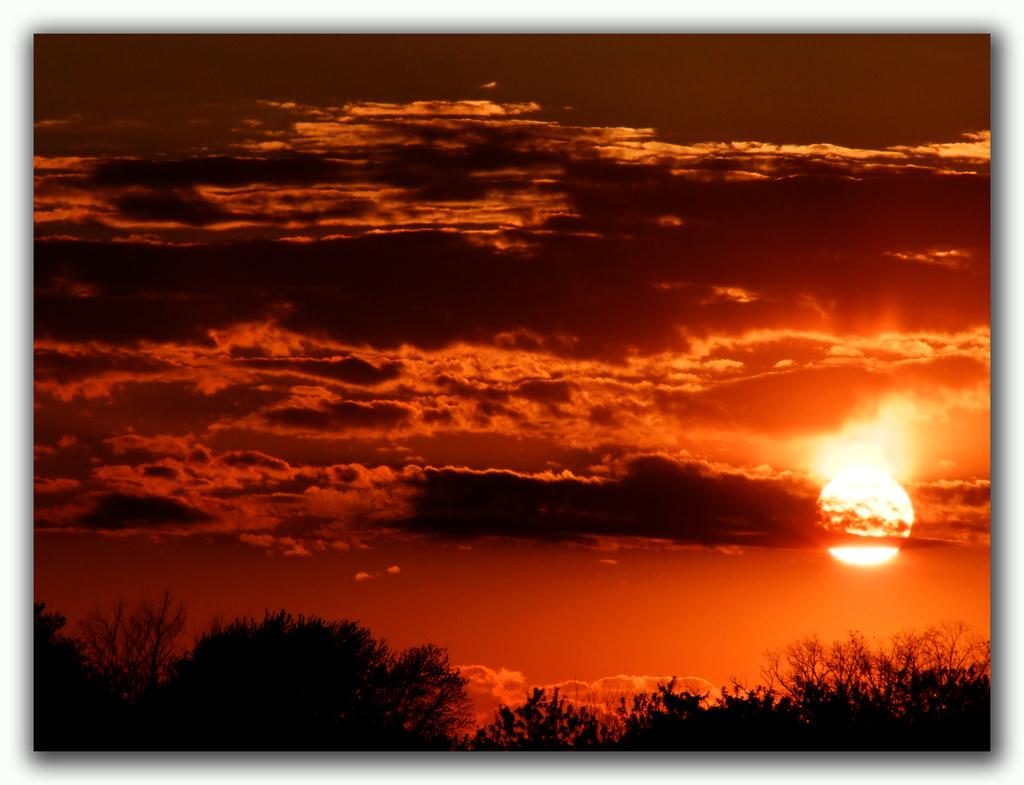What type of vegetation can be seen in the image? There are trees in the image. What is happening in the sky during the time the image was taken? There is a sunset in the sky. What is the weather like in the image? The sky is cloudy. How many women are pointing at the fish in the image? There are no women or fish present in the image. 